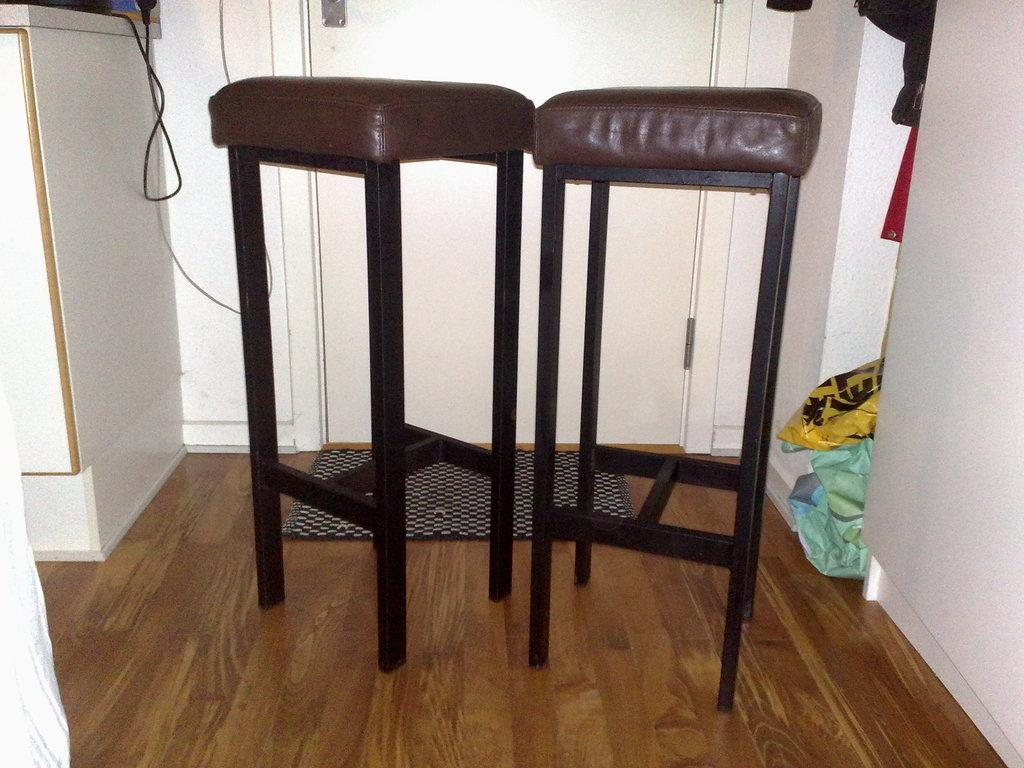What type of furniture is on the floor in the image? There are two stools on the floor in the image. What can be seen in the background of the image? There is a door, a cabinet, and a wire in the background of the image. Where might this image have been taken? The image is likely taken in a room, as indicated by the presence of furniture and a door. How many pears are on the feet of the person in the image? There are no pears or people present in the image, so this question cannot be answered. What type of street can be seen in the image? There is no street visible in the image; it appears to be taken in a room with a door, cabinet, and stools. 